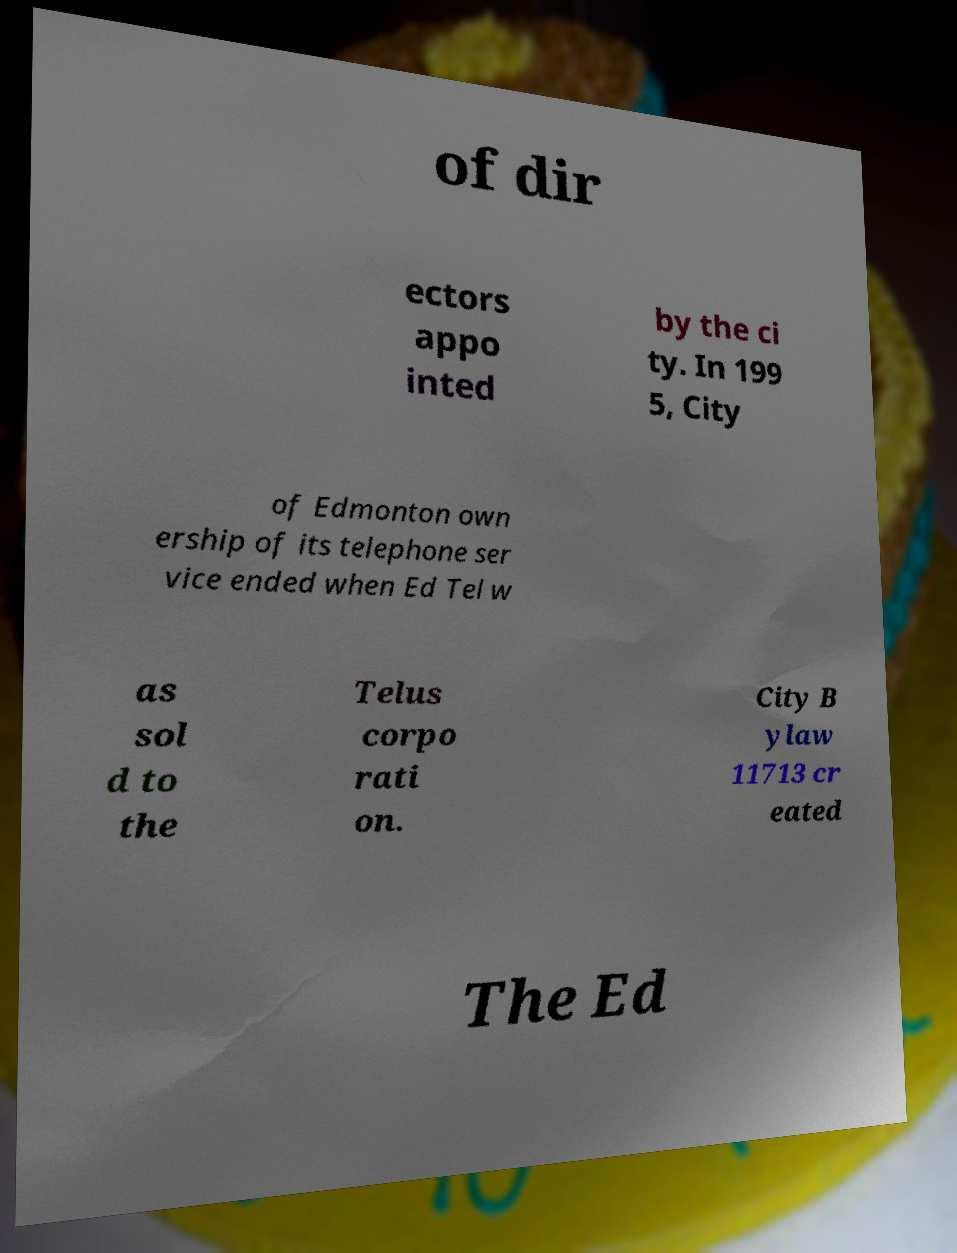Can you read and provide the text displayed in the image?This photo seems to have some interesting text. Can you extract and type it out for me? of dir ectors appo inted by the ci ty. In 199 5, City of Edmonton own ership of its telephone ser vice ended when Ed Tel w as sol d to the Telus corpo rati on. City B ylaw 11713 cr eated The Ed 